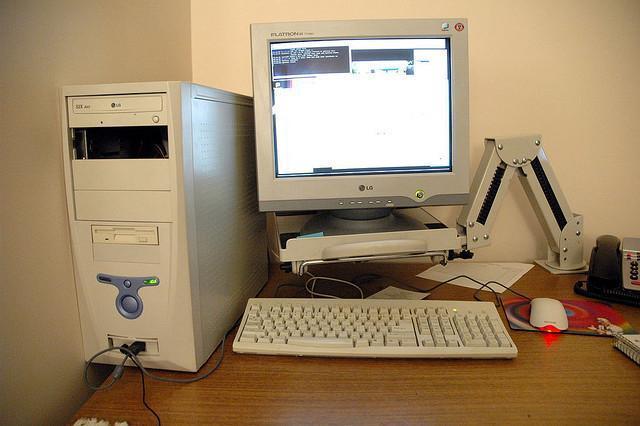How many keyboards are in the picture?
Give a very brief answer. 1. How many couches in this image are unoccupied by people?
Give a very brief answer. 0. 